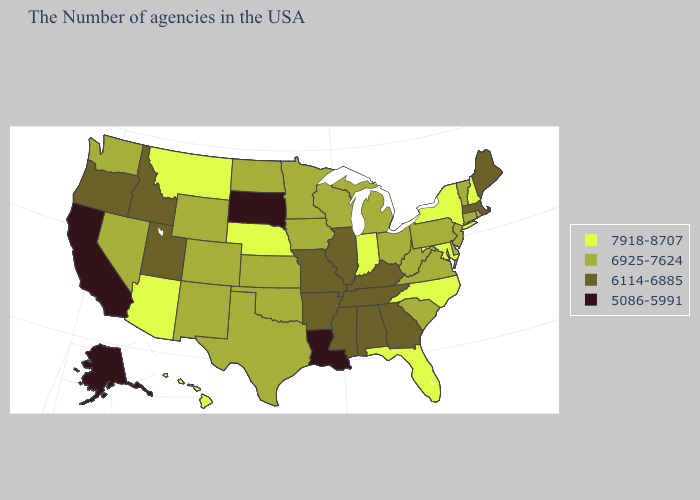What is the value of Pennsylvania?
Write a very short answer. 6925-7624. Name the states that have a value in the range 6925-7624?
Quick response, please. Rhode Island, Vermont, Connecticut, New Jersey, Delaware, Pennsylvania, Virginia, South Carolina, West Virginia, Ohio, Michigan, Wisconsin, Minnesota, Iowa, Kansas, Oklahoma, Texas, North Dakota, Wyoming, Colorado, New Mexico, Nevada, Washington. What is the value of Rhode Island?
Concise answer only. 6925-7624. Does Wisconsin have the lowest value in the MidWest?
Keep it brief. No. Does Louisiana have the lowest value in the USA?
Concise answer only. Yes. Which states have the highest value in the USA?
Keep it brief. New Hampshire, New York, Maryland, North Carolina, Florida, Indiana, Nebraska, Montana, Arizona, Hawaii. What is the value of Georgia?
Quick response, please. 6114-6885. Does South Dakota have the lowest value in the USA?
Write a very short answer. Yes. Name the states that have a value in the range 7918-8707?
Give a very brief answer. New Hampshire, New York, Maryland, North Carolina, Florida, Indiana, Nebraska, Montana, Arizona, Hawaii. Which states have the lowest value in the USA?
Write a very short answer. Louisiana, South Dakota, California, Alaska. Does Connecticut have the lowest value in the Northeast?
Answer briefly. No. What is the value of Connecticut?
Short answer required. 6925-7624. What is the highest value in the MidWest ?
Keep it brief. 7918-8707. What is the value of Massachusetts?
Write a very short answer. 6114-6885. Does Oklahoma have the highest value in the USA?
Answer briefly. No. 